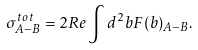Convert formula to latex. <formula><loc_0><loc_0><loc_500><loc_500>\sigma ^ { t o t } _ { A - B } = 2 R e \int d ^ { 2 } { b } F ( { b } ) _ { A - B } .</formula> 